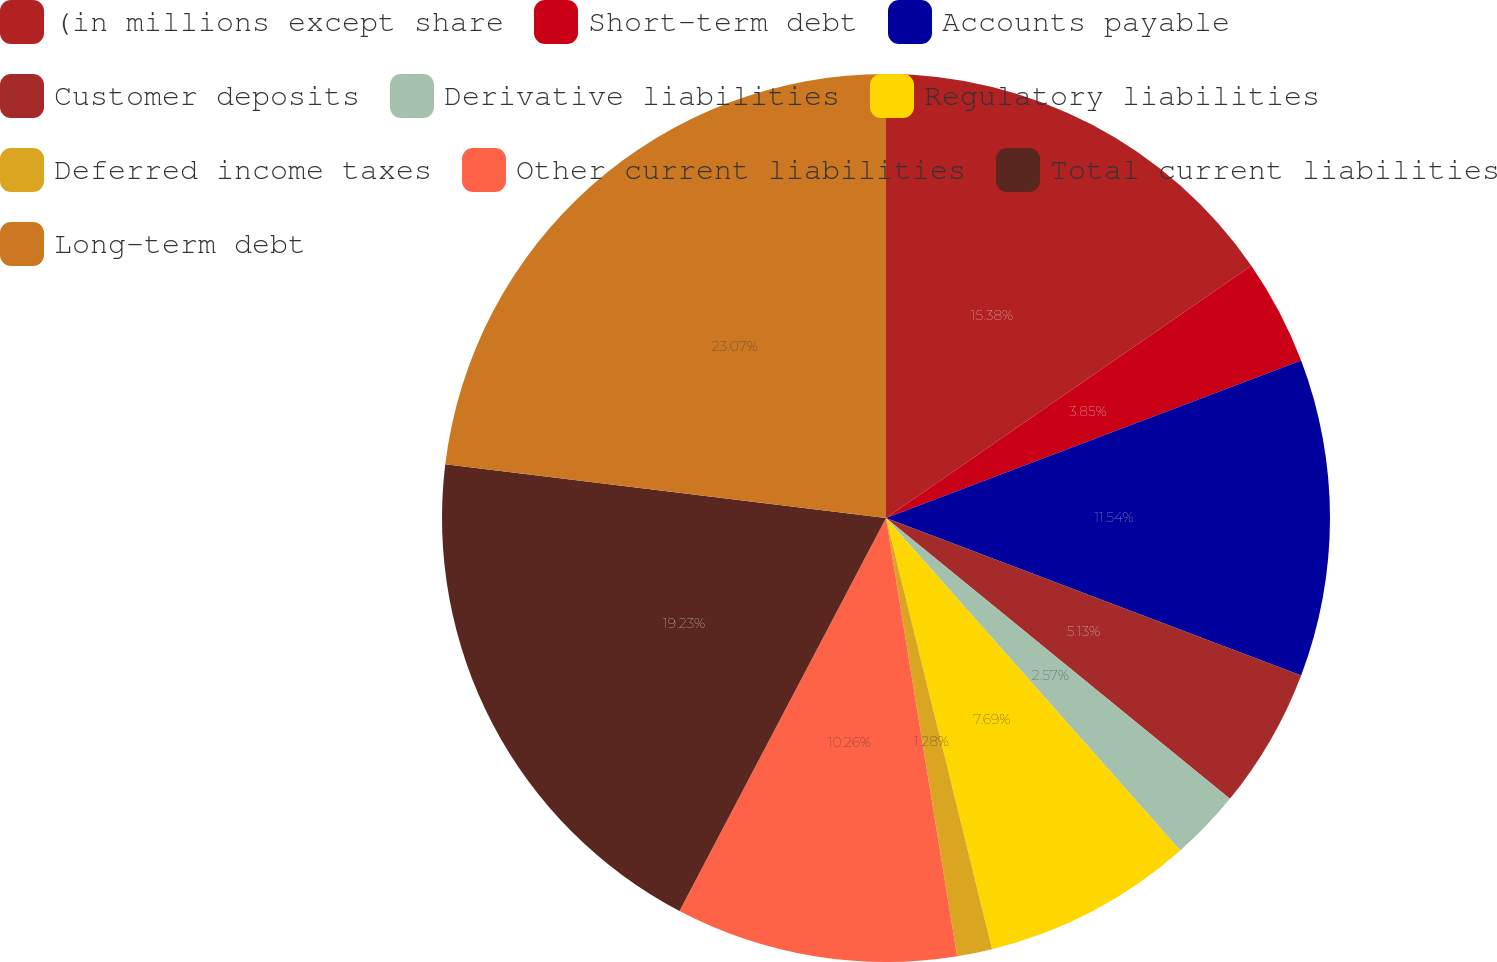<chart> <loc_0><loc_0><loc_500><loc_500><pie_chart><fcel>(in millions except share<fcel>Short-term debt<fcel>Accounts payable<fcel>Customer deposits<fcel>Derivative liabilities<fcel>Regulatory liabilities<fcel>Deferred income taxes<fcel>Other current liabilities<fcel>Total current liabilities<fcel>Long-term debt<nl><fcel>15.38%<fcel>3.85%<fcel>11.54%<fcel>5.13%<fcel>2.57%<fcel>7.69%<fcel>1.28%<fcel>10.26%<fcel>19.23%<fcel>23.07%<nl></chart> 